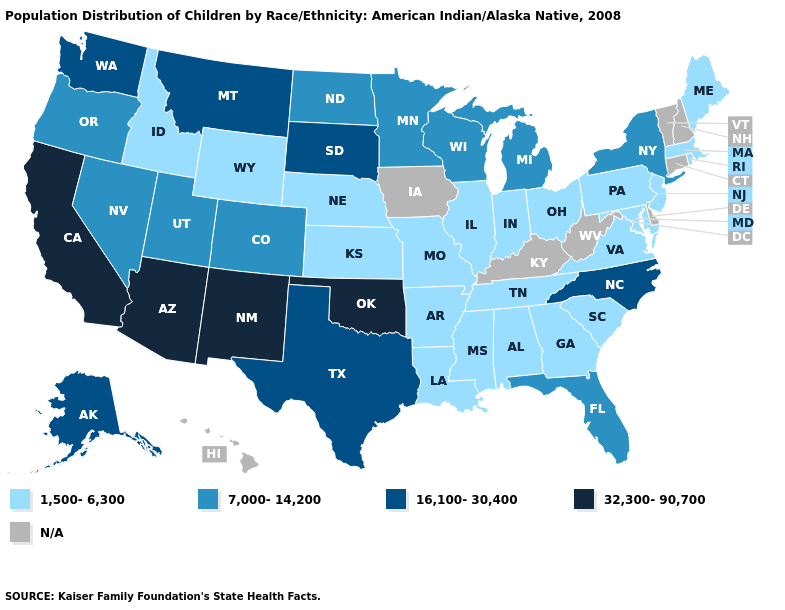Among the states that border California , which have the lowest value?
Give a very brief answer. Nevada, Oregon. Does New York have the highest value in the Northeast?
Short answer required. Yes. How many symbols are there in the legend?
Give a very brief answer. 5. Does North Dakota have the highest value in the MidWest?
Give a very brief answer. No. What is the value of Alaska?
Quick response, please. 16,100-30,400. Is the legend a continuous bar?
Keep it brief. No. How many symbols are there in the legend?
Give a very brief answer. 5. Name the states that have a value in the range 32,300-90,700?
Concise answer only. Arizona, California, New Mexico, Oklahoma. What is the value of West Virginia?
Answer briefly. N/A. Does Oklahoma have the highest value in the South?
Short answer required. Yes. What is the value of Georgia?
Write a very short answer. 1,500-6,300. What is the value of Louisiana?
Be succinct. 1,500-6,300. Does Montana have the highest value in the West?
Be succinct. No. What is the lowest value in the USA?
Concise answer only. 1,500-6,300. 